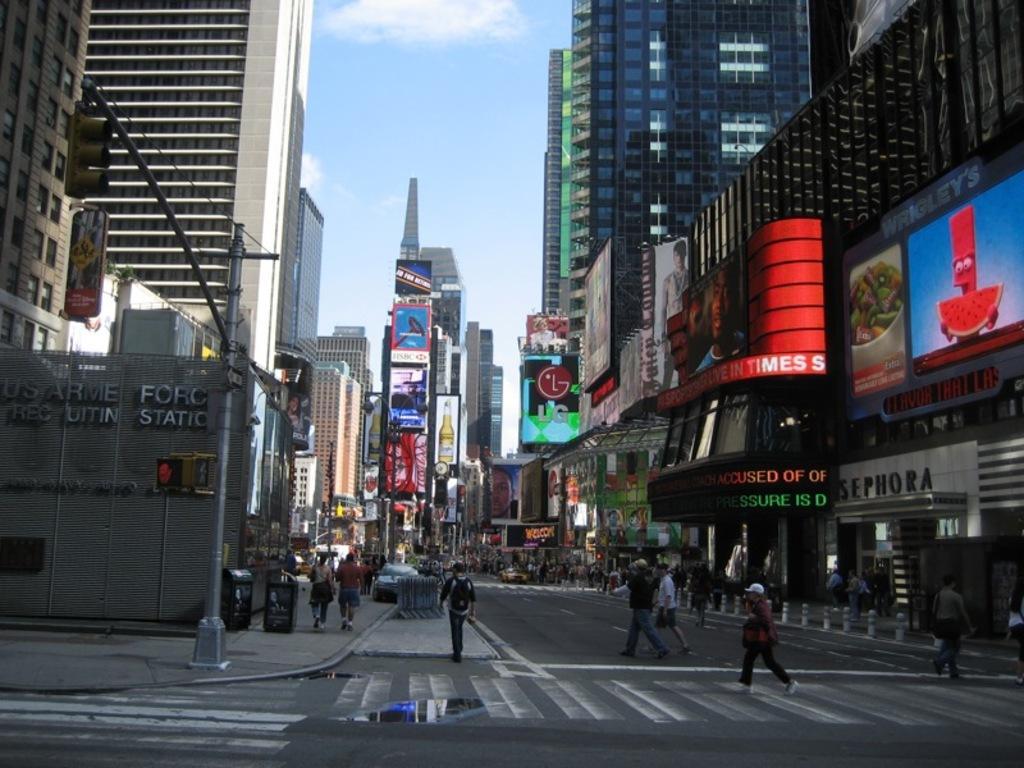In one or two sentences, can you explain what this image depicts? In the foreground of this image, there is a road on which persons walking on it. In the background, there are buildings, poles, screens, vehicle moving on the road, and persons. On the top, there is the sky. 